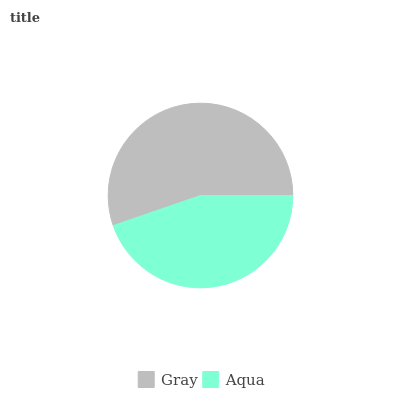Is Aqua the minimum?
Answer yes or no. Yes. Is Gray the maximum?
Answer yes or no. Yes. Is Aqua the maximum?
Answer yes or no. No. Is Gray greater than Aqua?
Answer yes or no. Yes. Is Aqua less than Gray?
Answer yes or no. Yes. Is Aqua greater than Gray?
Answer yes or no. No. Is Gray less than Aqua?
Answer yes or no. No. Is Gray the high median?
Answer yes or no. Yes. Is Aqua the low median?
Answer yes or no. Yes. Is Aqua the high median?
Answer yes or no. No. Is Gray the low median?
Answer yes or no. No. 